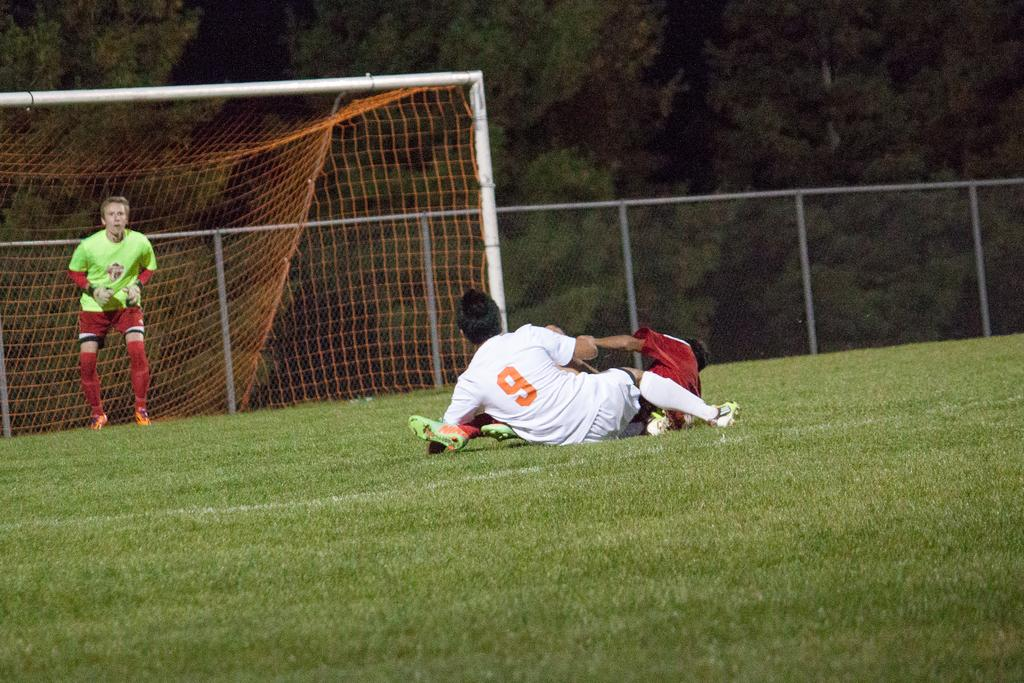<image>
Present a compact description of the photo's key features. A soccer player wearing number 9 fell to the ground. 